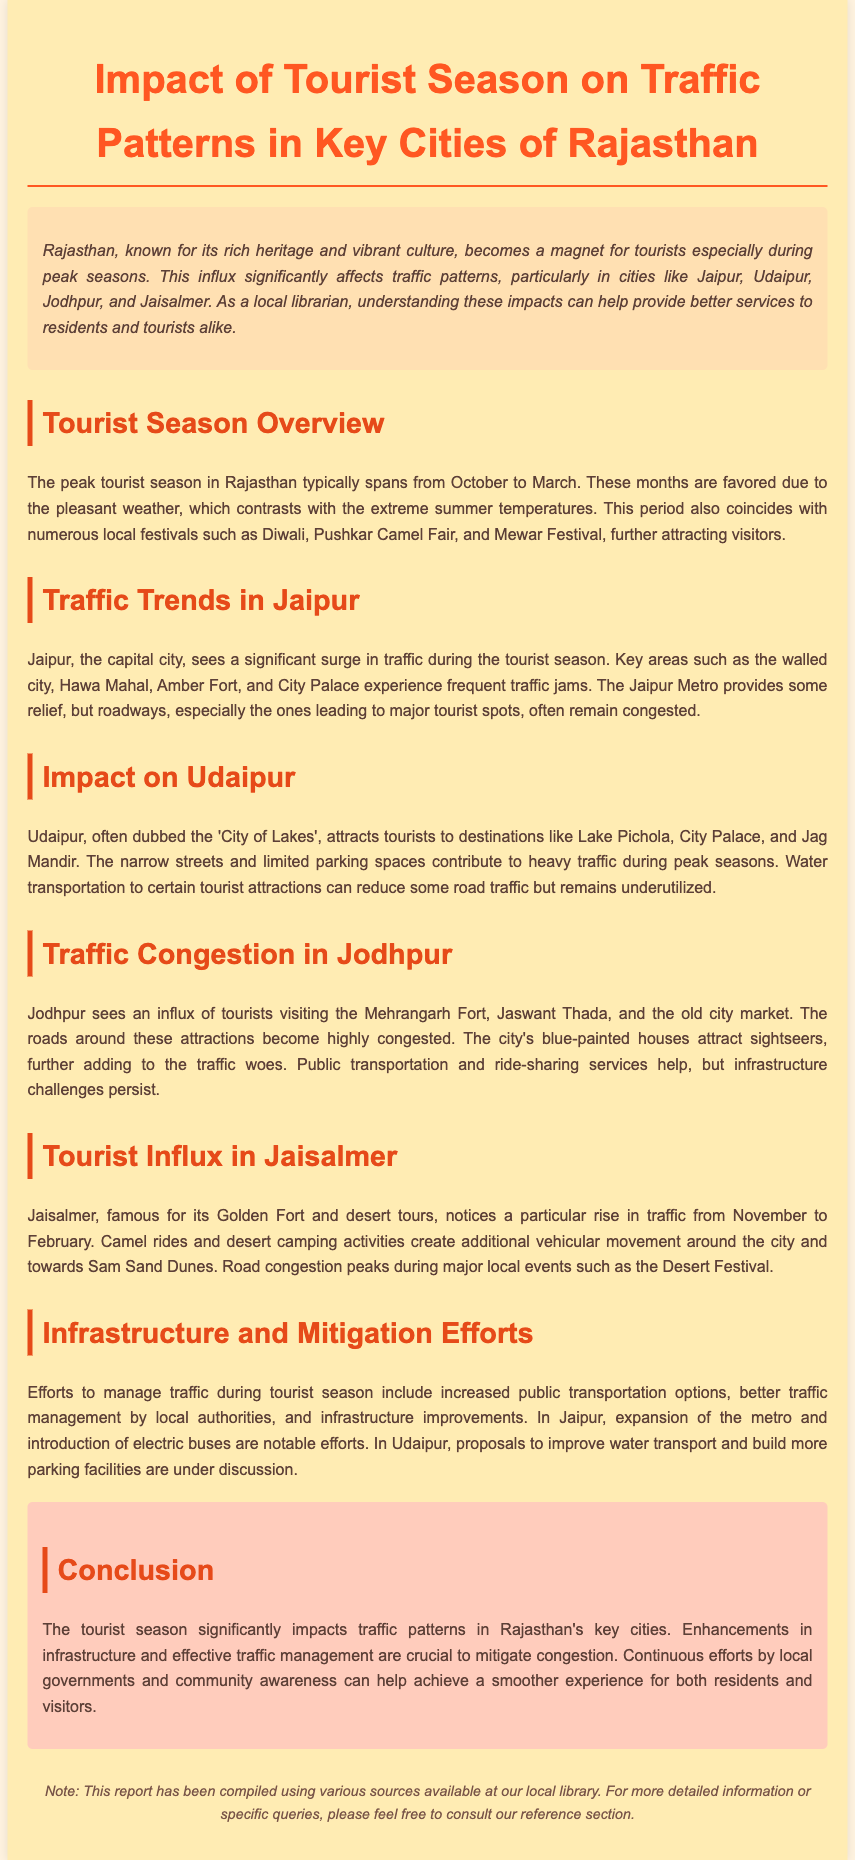What is the peak tourist season in Rajasthan? The document states that the peak tourist season spans from October to March due to pleasant weather.
Answer: October to March Which city experiences significant traffic jams at key tourist spots? Jaipur is mentioned as experiencing frequent traffic jams at major attractions like Hawa Mahal and Amber Fort.
Answer: Jaipur What is Udaipur often referred to as? Udaipur is dubbed the 'City of Lakes' in the report.
Answer: City of Lakes During which months does Jaisalmer see a rise in traffic? The document indicates that Jaisalmer sees increased traffic from November to February.
Answer: November to February What notable traffic management improvement has been introduced in Jaipur? The report highlights the expansion of the metro as a significant traffic management effort in Jaipur.
Answer: Expansion of the metro What local event contributes to increased congestion in Jaisalmer? The Desert Festival is mentioned as creating additional vehicular movement around Jaisalmer.
Answer: Desert Festival Why do streets in Udaipur become congested during peak season? The narrow streets and limited parking spaces contribute to heavy traffic in Udaipur.
Answer: Narrow streets and limited parking What is a proposed solution to traffic issues in Udaipur? The report discusses proposals to improve water transport as a possible solution for traffic management.
Answer: Improve water transport What cultural events coincide with the tourist season in Rajasthan? The document lists festivals such as Diwali, Pushkar Camel Fair, and Mewar Festival as coinciding with the tourist season.
Answer: Diwali, Pushkar Camel Fair, Mewar Festival 